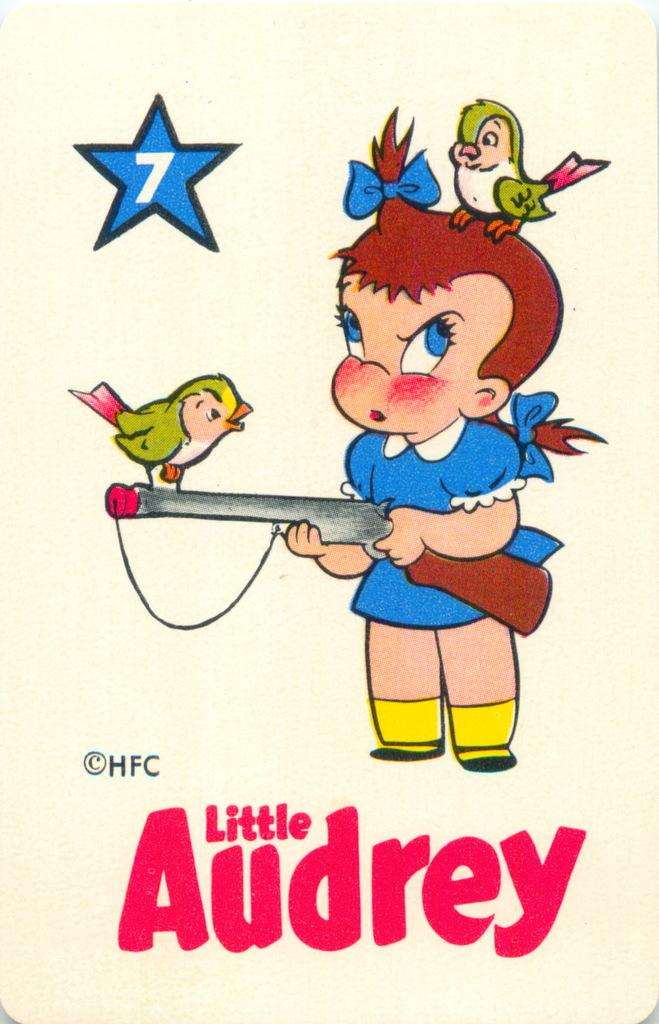What type of images are present in the image? There are cartoon pictures in the image. What else can be seen in the image besides the cartoon pictures? There is text on a paper in the image. How many geese are depicted in the cartoon pictures in the image? There is no information about geese in the image; it only contains cartoon pictures and text on a paper. What type of bun is being used to write the text on the paper in the image? There is no bun present in the image; it only contains cartoon pictures and text on a paper. 